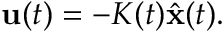Convert formula to latex. <formula><loc_0><loc_0><loc_500><loc_500>{ u } ( t ) = - K ( t ) { \hat { x } } ( t ) .</formula> 